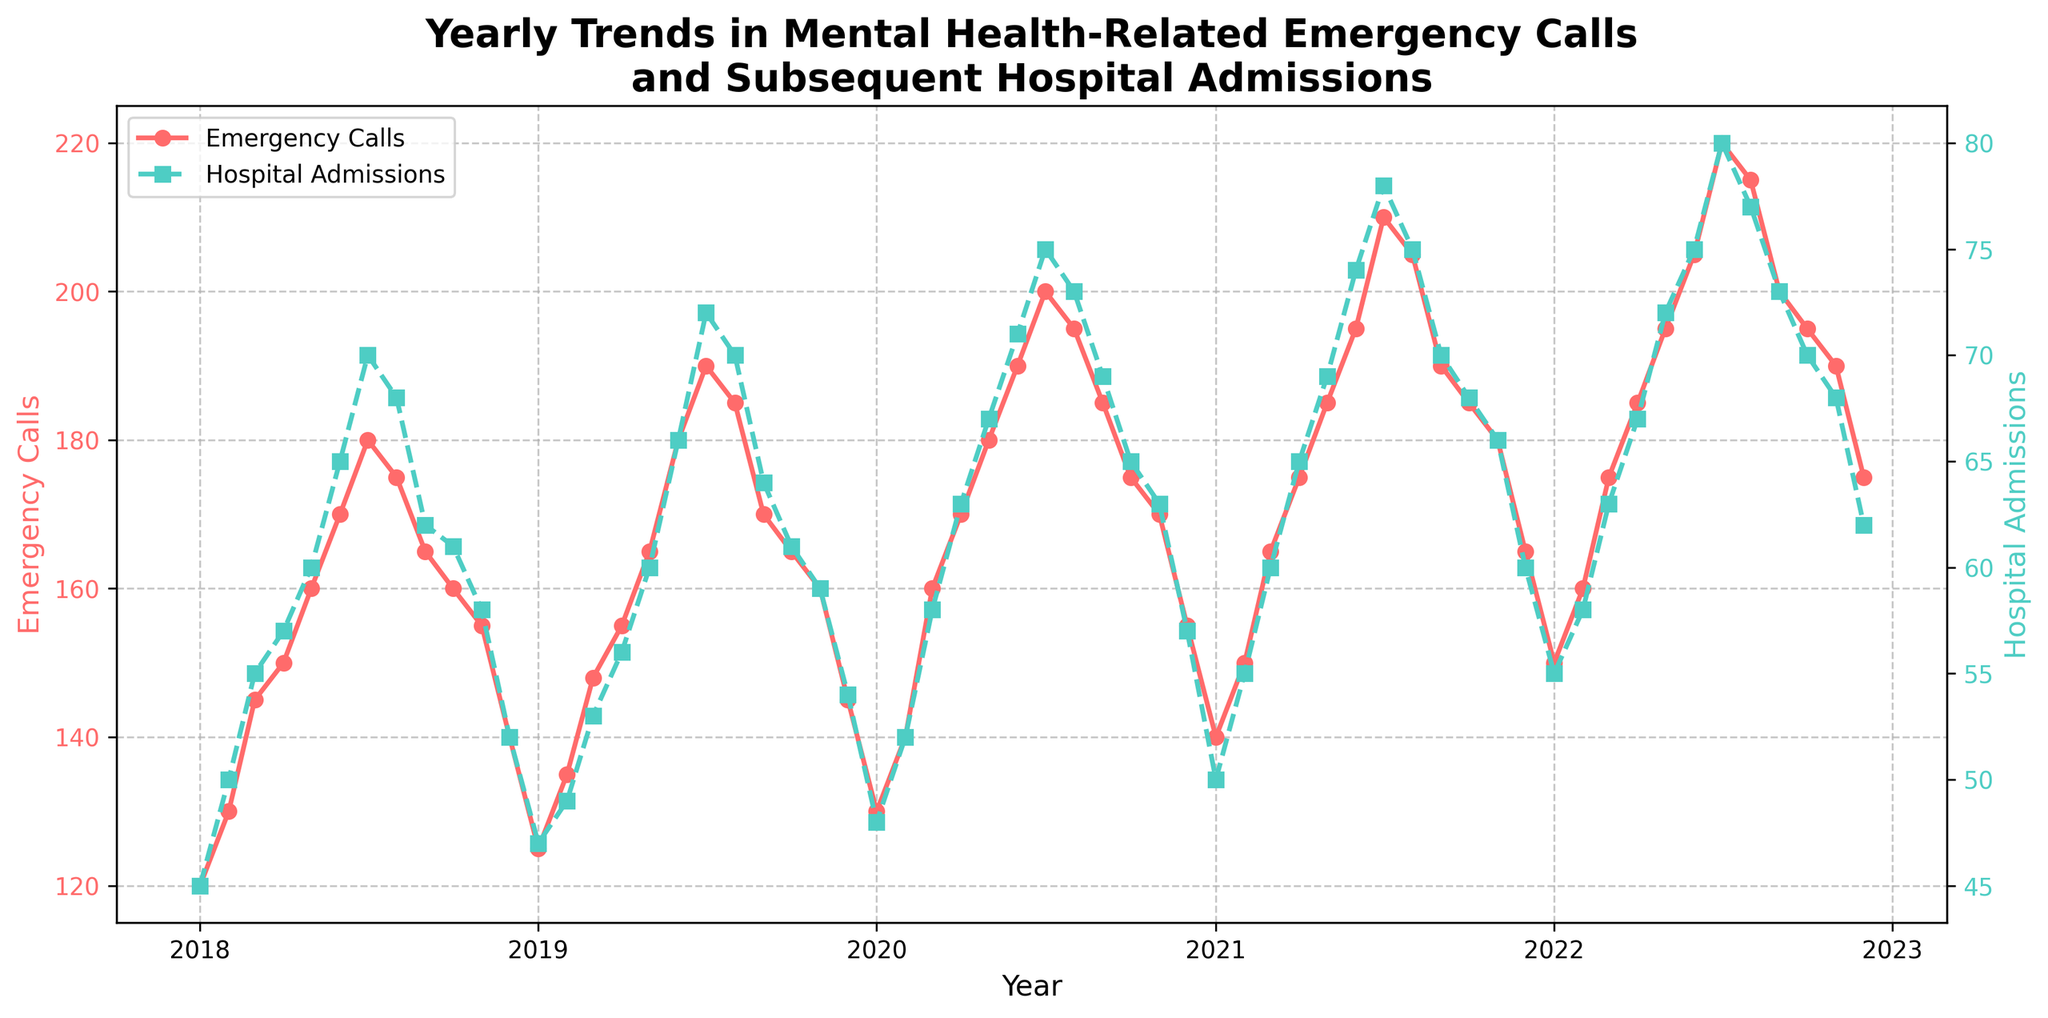What does the title of the plot indicate? The title of a plot provides an overview of its content, which in this case is described as "Yearly Trends in Mental Health-Related Emergency Calls and Subsequent Hospital Admissions," suggesting that the plot depicts changes over time in these two metrics.
Answer: Yearly Trends in Mental Health-Related Emergency Calls and Subsequent Hospital Admissions How many y-axes are present in this figure? By looking at the figure, it is apparent that there are two y-axes present because one is used for emergency calls and the other is used for hospital admissions, each labeled and colored differently.
Answer: Two When is the peak in emergency calls reached in 2022? The peak for emergency calls in 2022 can be identified by noticing the highest point in the time series line, which occurs in July 2022.
Answer: July 2022 What color represents hospital admissions in the plot? Hospital admissions are represented by the color green in the plot. This can be identified by looking at the legend or the y-axis label for hospital admissions.
Answer: Green Which year shows the highest number of emergency calls in the month of July? Examining each July in the time series, the highest peak in the emergency calls line is seen in July 2022.
Answer: 2022 How does the number of hospital admissions in December 2020 compare to January 2021? To compare the two points, observe that hospital admissions in December 2020 are 57, whereas in January 2021 they are 50, indicating a decrease.
Answer: Decrease What is the average number of hospital admissions from January to December in 2019? To compute the average, sum all the hospital admissions for each month in 2019 (47+49+53+56+60+66+72+70+64+61+59+54 = 711) and divide by 12. 711/12 = 59.25.
Answer: 59.25 Is there a trend between emergency calls and hospital admissions? Both lines tend to follow similar patterns, increasing and decreasing together, indicating a correlation between emergency calls and hospital admissions over time.
Answer: Correlated Trend Which year had the most stable (least varying) number of emergency calls over the months? Comparing the amplitude of variations in the graph for each year, 2018 displays the smallest fluctuations in emergency calls month-to-month.
Answer: 2018 Are there any months where emergency calls increased but hospital admissions decreased? Reviewing the figure month by month, there aren't instances where emergency calls increase while hospital admissions decrease, indicating they generally move together.
Answer: None 